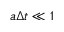<formula> <loc_0><loc_0><loc_500><loc_500>a \Delta t \ll 1</formula> 